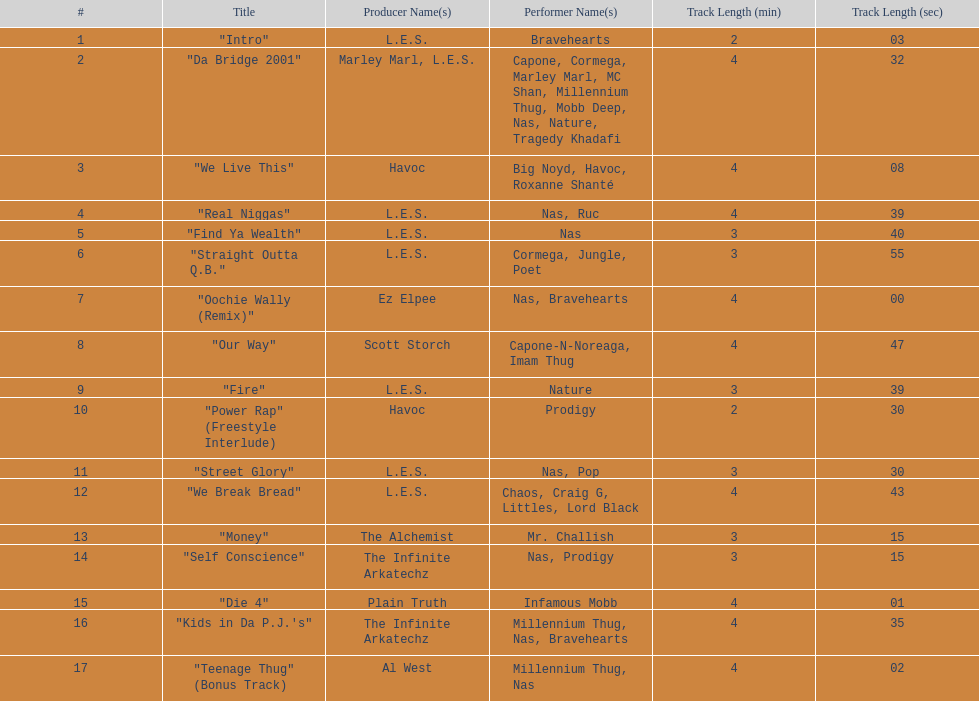How long is the shortest song on the album? 2:03. 